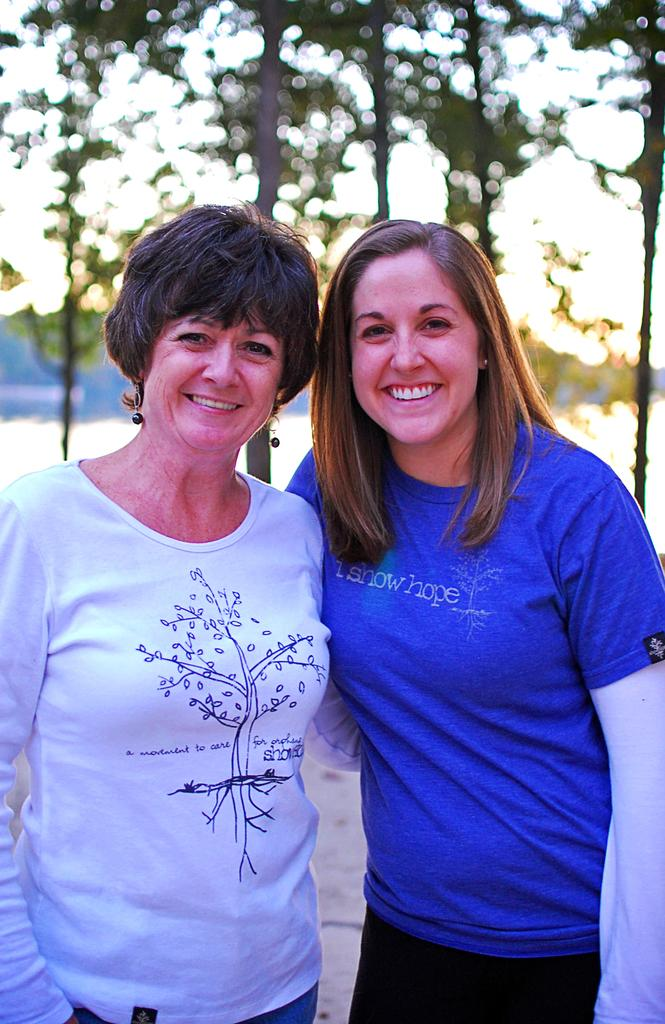How many people are in the image? There are two women in the image. What are the women doing in the image? The women are smiling and standing. What can be seen in the background of the image? There are trees visible in the background of the image. How would you describe the background of the image? The background appears blurry. What type of fruit is being discussed by the women in the image? There is no indication in the image that the women are discussing fruit, as their expressions and actions do not suggest any conversation. 